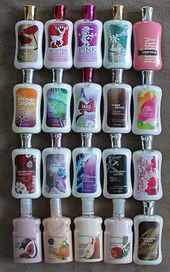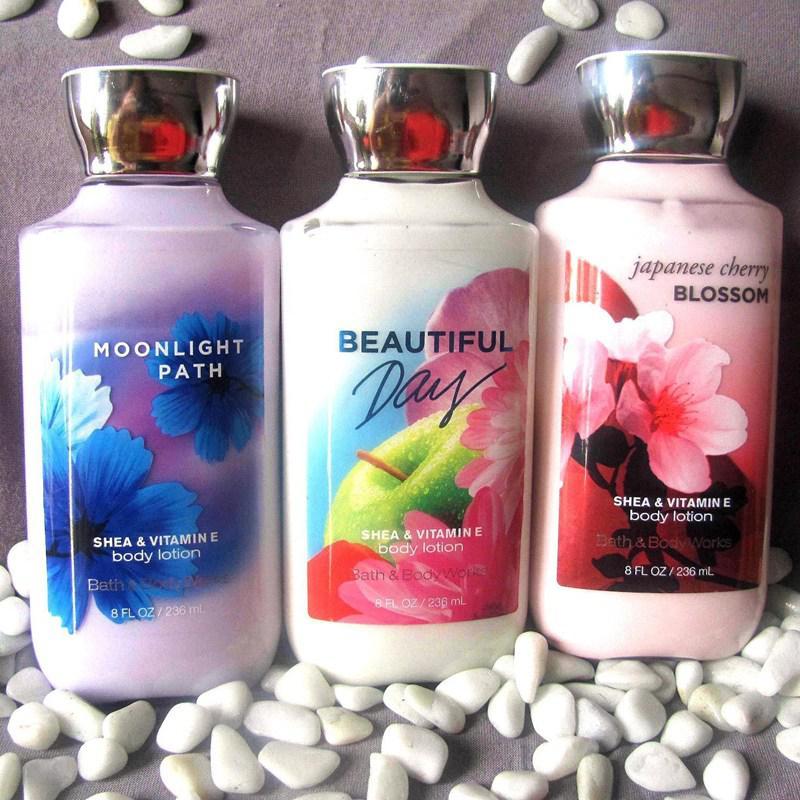The first image is the image on the left, the second image is the image on the right. For the images displayed, is the sentence "There are more than seven bath products." factually correct? Answer yes or no. Yes. The first image is the image on the left, the second image is the image on the right. Examine the images to the left and right. Is the description "An image contains at least one horizontal row of five skincare products of the same size and shape." accurate? Answer yes or no. Yes. 